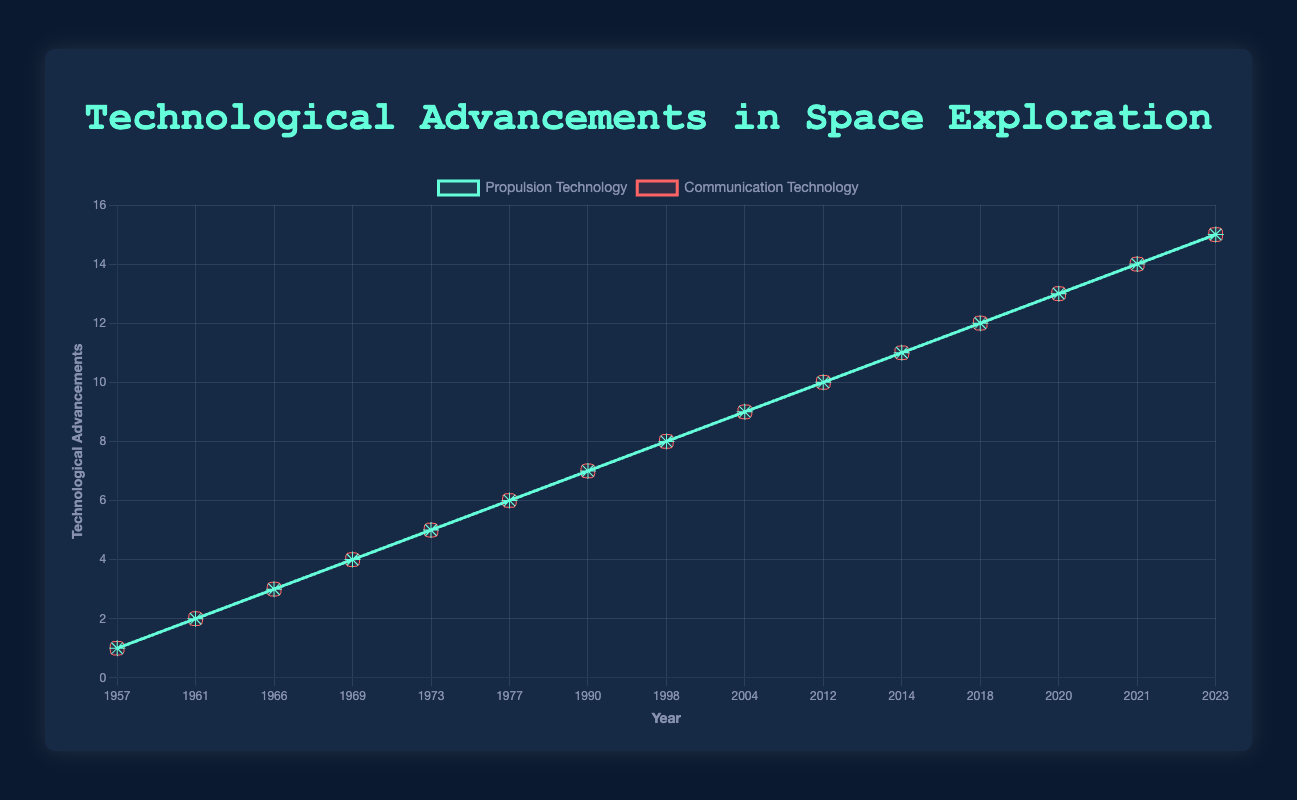Which year marked both a propulsion and communication breakthrough involving the same mission? The year 1957 marked both propulsion (Launch of Sputnik 1) and communication (Sputnik 1 Transmits Radio Signals) breakthroughs.
Answer: 1957 Which propulsion technology breakthrough occurred just before the first highly-advanced Deep Space Network antennas in 1983? The propulsion technology breakthrough occurring just before 1983 was the Launch of the Voyager Probes in 1977.
Answer: 1977 How many years after the Apollo 11 Moon Landing was the Curiosity Rover landing on Mars? The Apollo 11 Moon Landing was in 1969, and the Curiosity Rover landed on Mars in 2012. The difference is 2012 - 1969 = 43 years.
Answer: 43 Between 1966 and 1998, did more breakthroughs occur in propulsion technology or communication technology? First, count the number of breakthroughs for each: Propulsion: 4 (1966, 1969, 1973, 1977); Communication: 2 (1972, 1983). More breakthroughs occurred in propulsion technology.
Answer: propulsion technology Which communication technology breakthrough is visually represented with a rounded rectangle? The dialog mentions that the communication technology breakthroughs are represented with rounded rectangles. We can infer that this is true for all of them, such as "Sputnik 1 Transmits Radio Signals" in 1957.
Answer: Sputnik 1 Transmits Radio Signals What is the time gap between the breakthroughs of the first highly-advanced Deep Space Network antennas and the interplanetary internet for space communications? The first highly-advanced Deep Space Network antennas were developed in 1983, and the interplanetary internet for space communications came in 2000. The gap is 2000 - 1983 = 17 years.
Answer: 17 Was the James Webb Space Telescope launch closer to the Curiosity Rover landing on Mars or the Parker Solar Probe launch? The James Webb Space Telescope was launched in 2021. The Curiosity Rover landed in 2012; difference is 2021 - 2012 = 9 years. The Parker Solar Probe launched in 2018; difference is 2021 - 2018 = 3 years. The James Webb Space Telescope is closer to the Parker Solar Probe launch.
Answer: Parker Solar Probe launch Compare the number of breakthroughs in propulsion technology in the 1960s with those in the 2010s. Which decade had more breakthroughs? 1960s: 3 breakthroughs (1961, 1966, 1969). 2010s: 3 breakthroughs (2012, 2014, 2018). Both decades had the same number of breakthroughs.
Answer: Same 